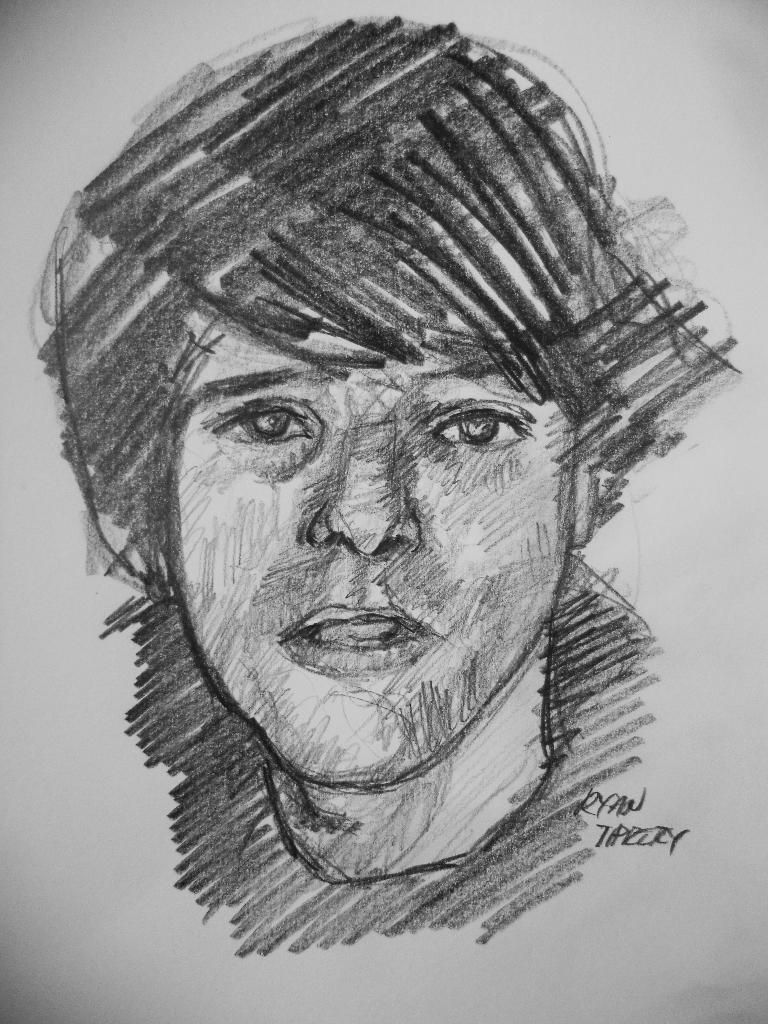What is depicted on the paper in the image? There is a drawing of a person's face on a paper. What else can be seen in the image besides the drawing? There is text visible in the image. Where is the boat located in the image? There is no boat present in the image. How many family members are depicted in the image? There is no family depicted in the image; it only features a drawing of a person's face and text. 